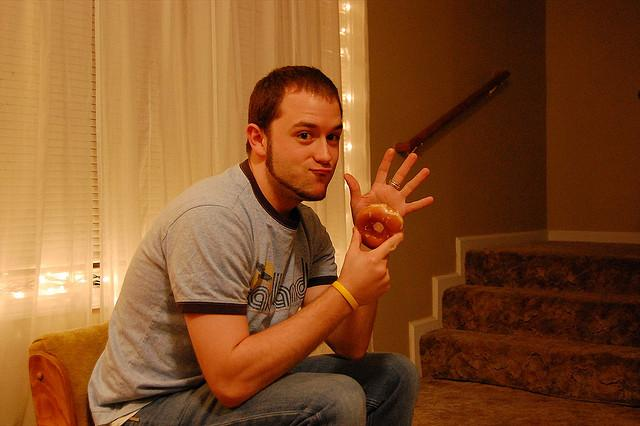What flavor is the donut? Please explain your reasoning. caramel. The donut has a caramel colored glaze on it. 